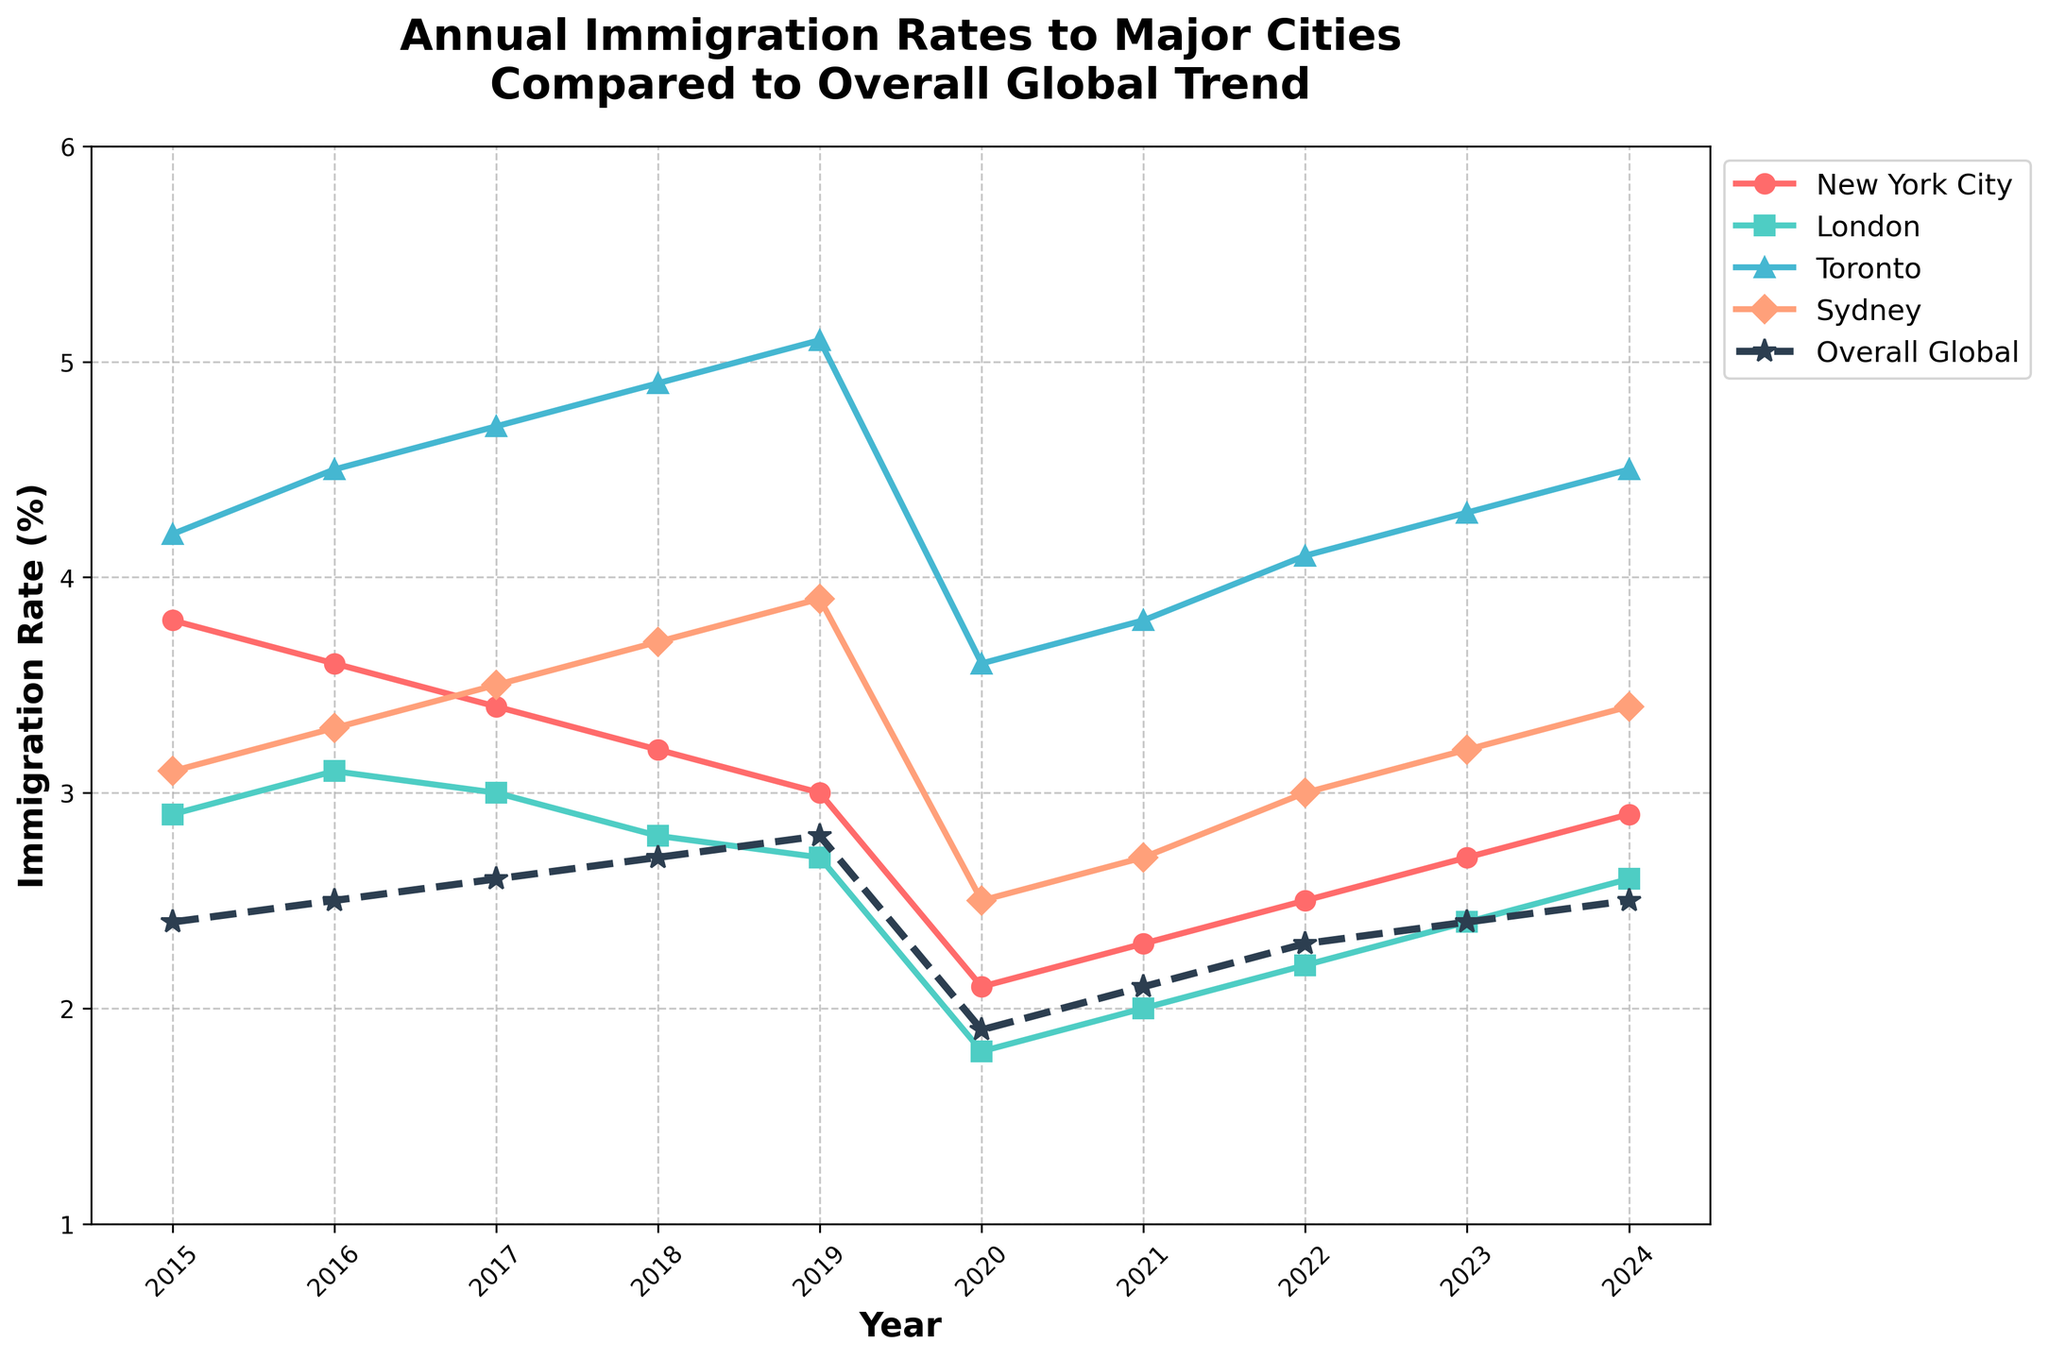What is the overall trend in immigration rates for New York City from 2015 to 2024? The figure shows a solid red line with circular markers representing New York City's immigration rates. From 2015 to 2020, there's a clear decline from 3.8% to 2.1%. After 2020, the rate shows a gradual increase, reaching 2.9% in 2024.
Answer: Decrease initially, then increase Which city had the highest immigration rate in 2019? By observing the peak points of each city for the year 2019, Toronto (blue line with triangular markers) has the highest rate, which is 5.1%.
Answer: Toronto Compare the overall global immigration rate in 2020 to the same rate in 2023. Which is higher? The dashed dark line represents the overall global rate. Looking at the values for 2020 and 2023, the rate in 2020 is 1.9%, and it increases to 2.4% in 2023.
Answer: 2023 Among the cities listed, which one shows the least variability in immigration rates over the years? By examining the smoothness and changes in the lines, London's rate (green line with square markers) has the least variability as it fluctuates within a smaller range compared to others.
Answer: London What is the difference in immigration rates for Sydney between 2020 and 2024? The hexagon-marked orange line shows Sydney’s rates. In 2020, it is 2.5% and rises to 3.4% in 2024. The difference is calculated as 3.4% - 2.5%.
Answer: 0.9% How does the trend for Toronto’s immigration rates compare to the global trend in the same period? The triangular-marked blue line shows Toronto's rates, consistently higher than the global rate indicated by the dashed line. Toronto shows a steady rise, except for a dip in 2020 and 2021, followed by continuous growth, paralleling the global trend but at higher rates.
Answer: Steadily higher than global rates with a similar trend Identify the year with the largest decrease in immigration rates for any city and name the city. Observing sharp declines in the lines, 2020 shows the most significant drop. New York City’s rate falls sharply from 3.0% in 2019 to 2.1% in 2020.
Answer: 2020, New York City Which city shows a rate pattern that most closely follows the overall global immigration trend? By comparing the lines’ shapes to the dashed global line, Sydney’s pattern (orange hexagon-marked line) appears to most closely mirror the overall global trend, mainly the steady increase albeit at higher values.
Answer: Sydney Calculate the average immigration rate for London from 2015 to 2024. The green line with square markers shows London’s rates. Summing them gives 2.9 + 3.1 + 3.0 + 2.8 + 2.7 + 1.8 + 2.0 + 2.2 + 2.4 + 2.6 = 25.5. Dividing by 10 (number of years) gives 25.5 / 10.
Answer: 2.55 